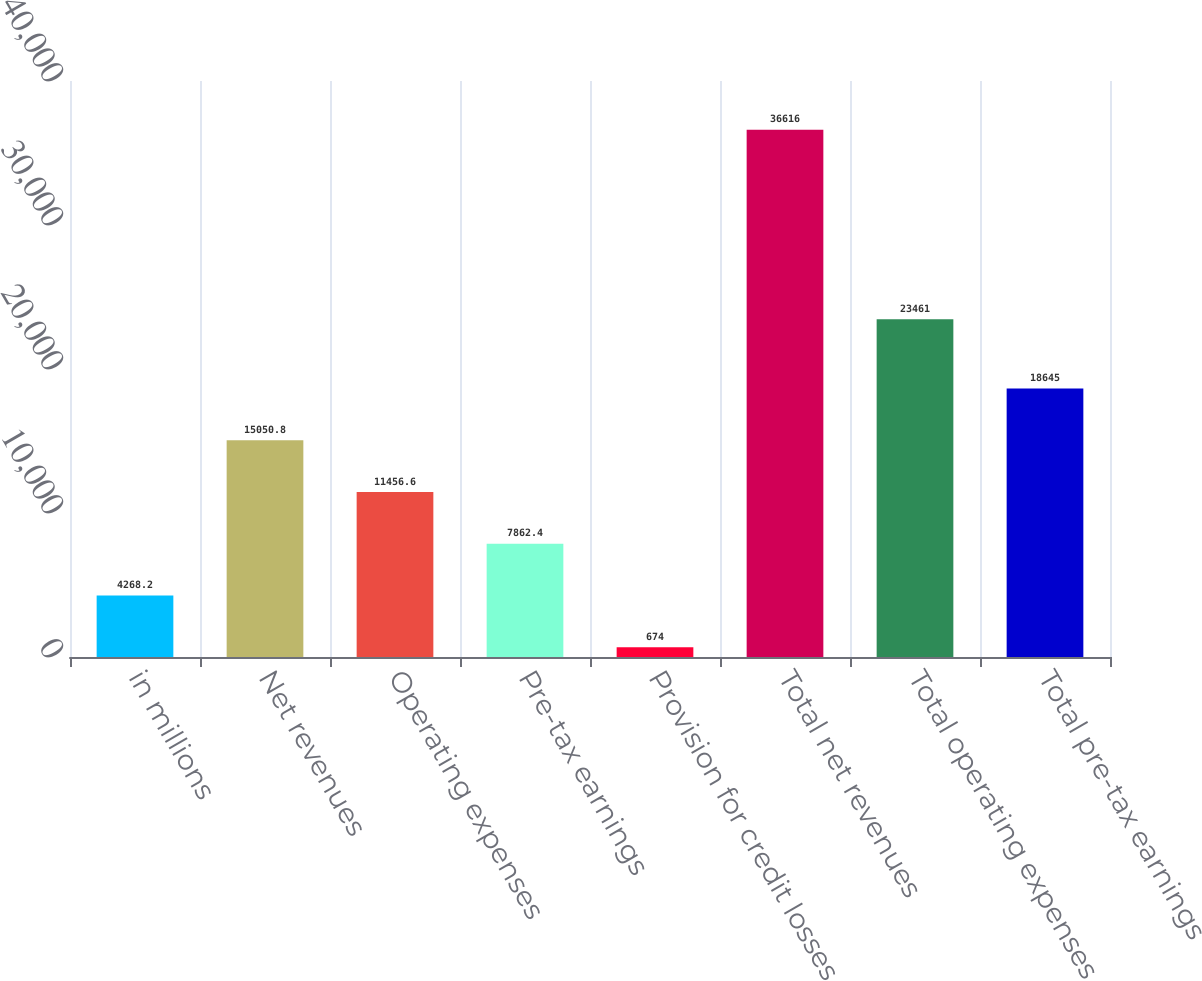Convert chart to OTSL. <chart><loc_0><loc_0><loc_500><loc_500><bar_chart><fcel>in millions<fcel>Net revenues<fcel>Operating expenses<fcel>Pre-tax earnings<fcel>Provision for credit losses<fcel>Total net revenues<fcel>Total operating expenses<fcel>Total pre-tax earnings<nl><fcel>4268.2<fcel>15050.8<fcel>11456.6<fcel>7862.4<fcel>674<fcel>36616<fcel>23461<fcel>18645<nl></chart> 